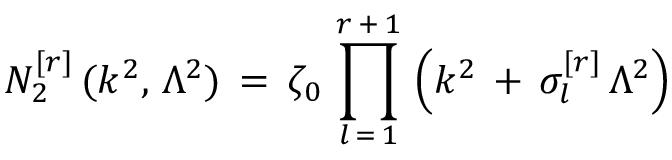Convert formula to latex. <formula><loc_0><loc_0><loc_500><loc_500>N _ { 2 } ^ { [ r ] } \, ( k ^ { 2 } , \, \Lambda ^ { 2 } ) \, = \, \zeta _ { 0 } \, \prod _ { l \, = \, 1 } ^ { r \, + \, 1 } \, \left ( k ^ { 2 } \, + \, \sigma _ { l } ^ { [ r ] } \, \Lambda ^ { 2 } \right )</formula> 